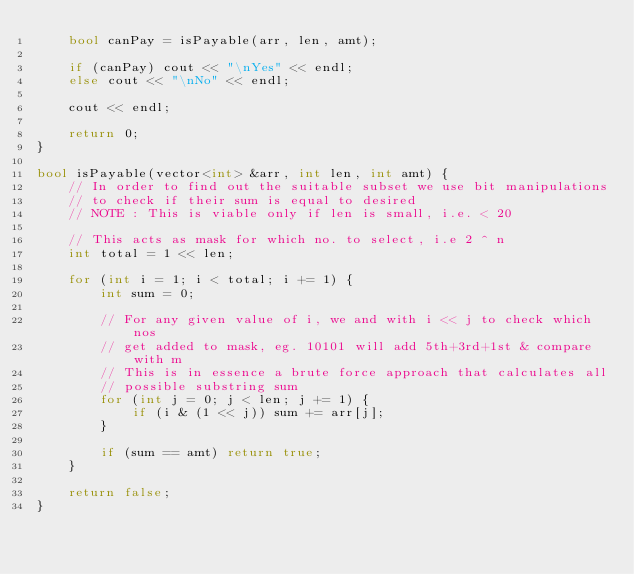<code> <loc_0><loc_0><loc_500><loc_500><_C++_>    bool canPay = isPayable(arr, len, amt);

    if (canPay) cout << "\nYes" << endl;
    else cout << "\nNo" << endl;

    cout << endl;

    return 0;
}

bool isPayable(vector<int> &arr, int len, int amt) {
    // In order to find out the suitable subset we use bit manipulations 
    // to check if their sum is equal to desired
    // NOTE : This is viable only if len is small, i.e. < 20

    // This acts as mask for which no. to select, i.e 2 ^ n
    int total = 1 << len;

    for (int i = 1; i < total; i += 1) {
        int sum = 0;

        // For any given value of i, we and with i << j to check which nos
        // get added to mask, eg. 10101 will add 5th+3rd+1st & compare with m
        // This is in essence a brute force approach that calculates all
        // possible substring sum
        for (int j = 0; j < len; j += 1) {
            if (i & (1 << j)) sum += arr[j];
        }

        if (sum == amt) return true;
    }

    return false;
}</code> 